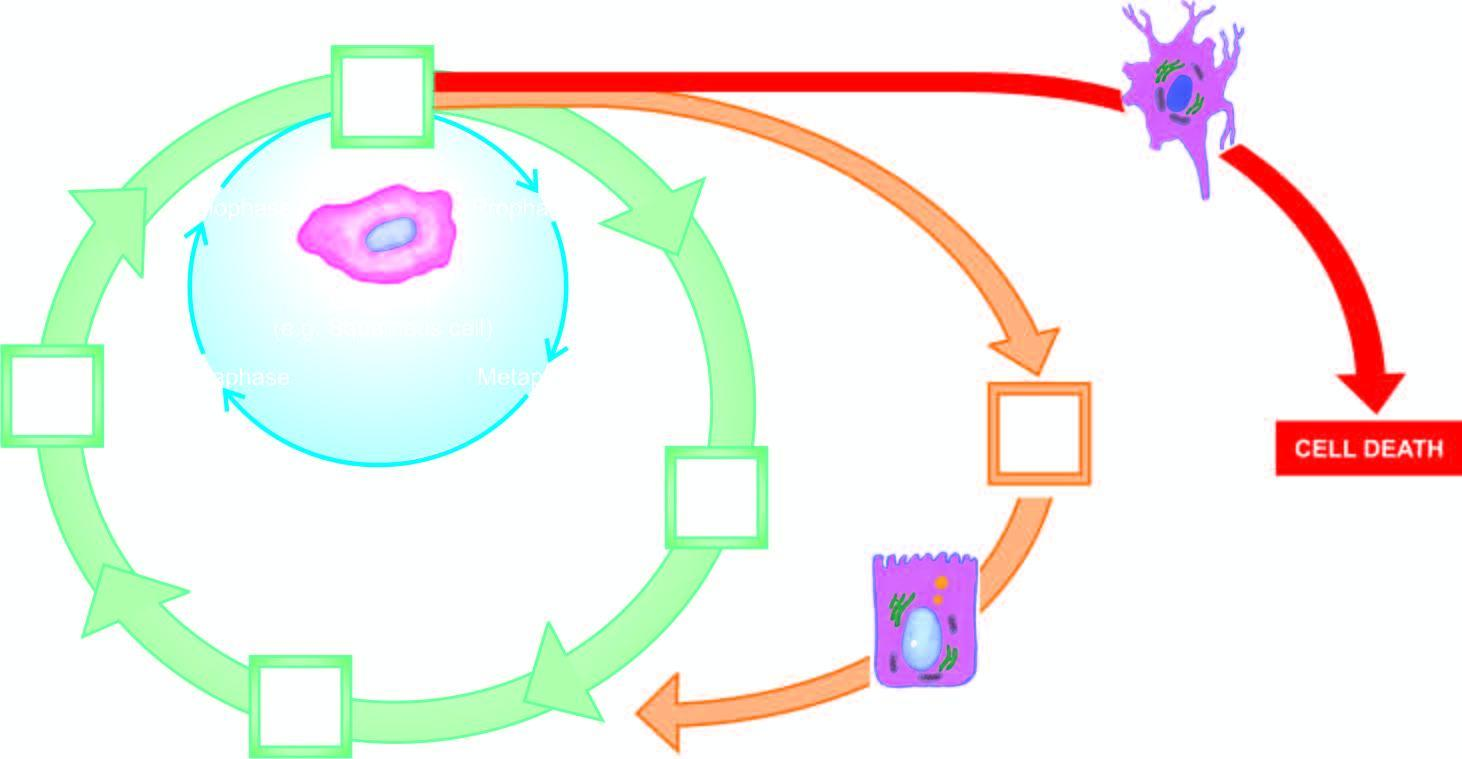does adp represent cell cycle for permanent cells?
Answer the question using a single word or phrase. No 